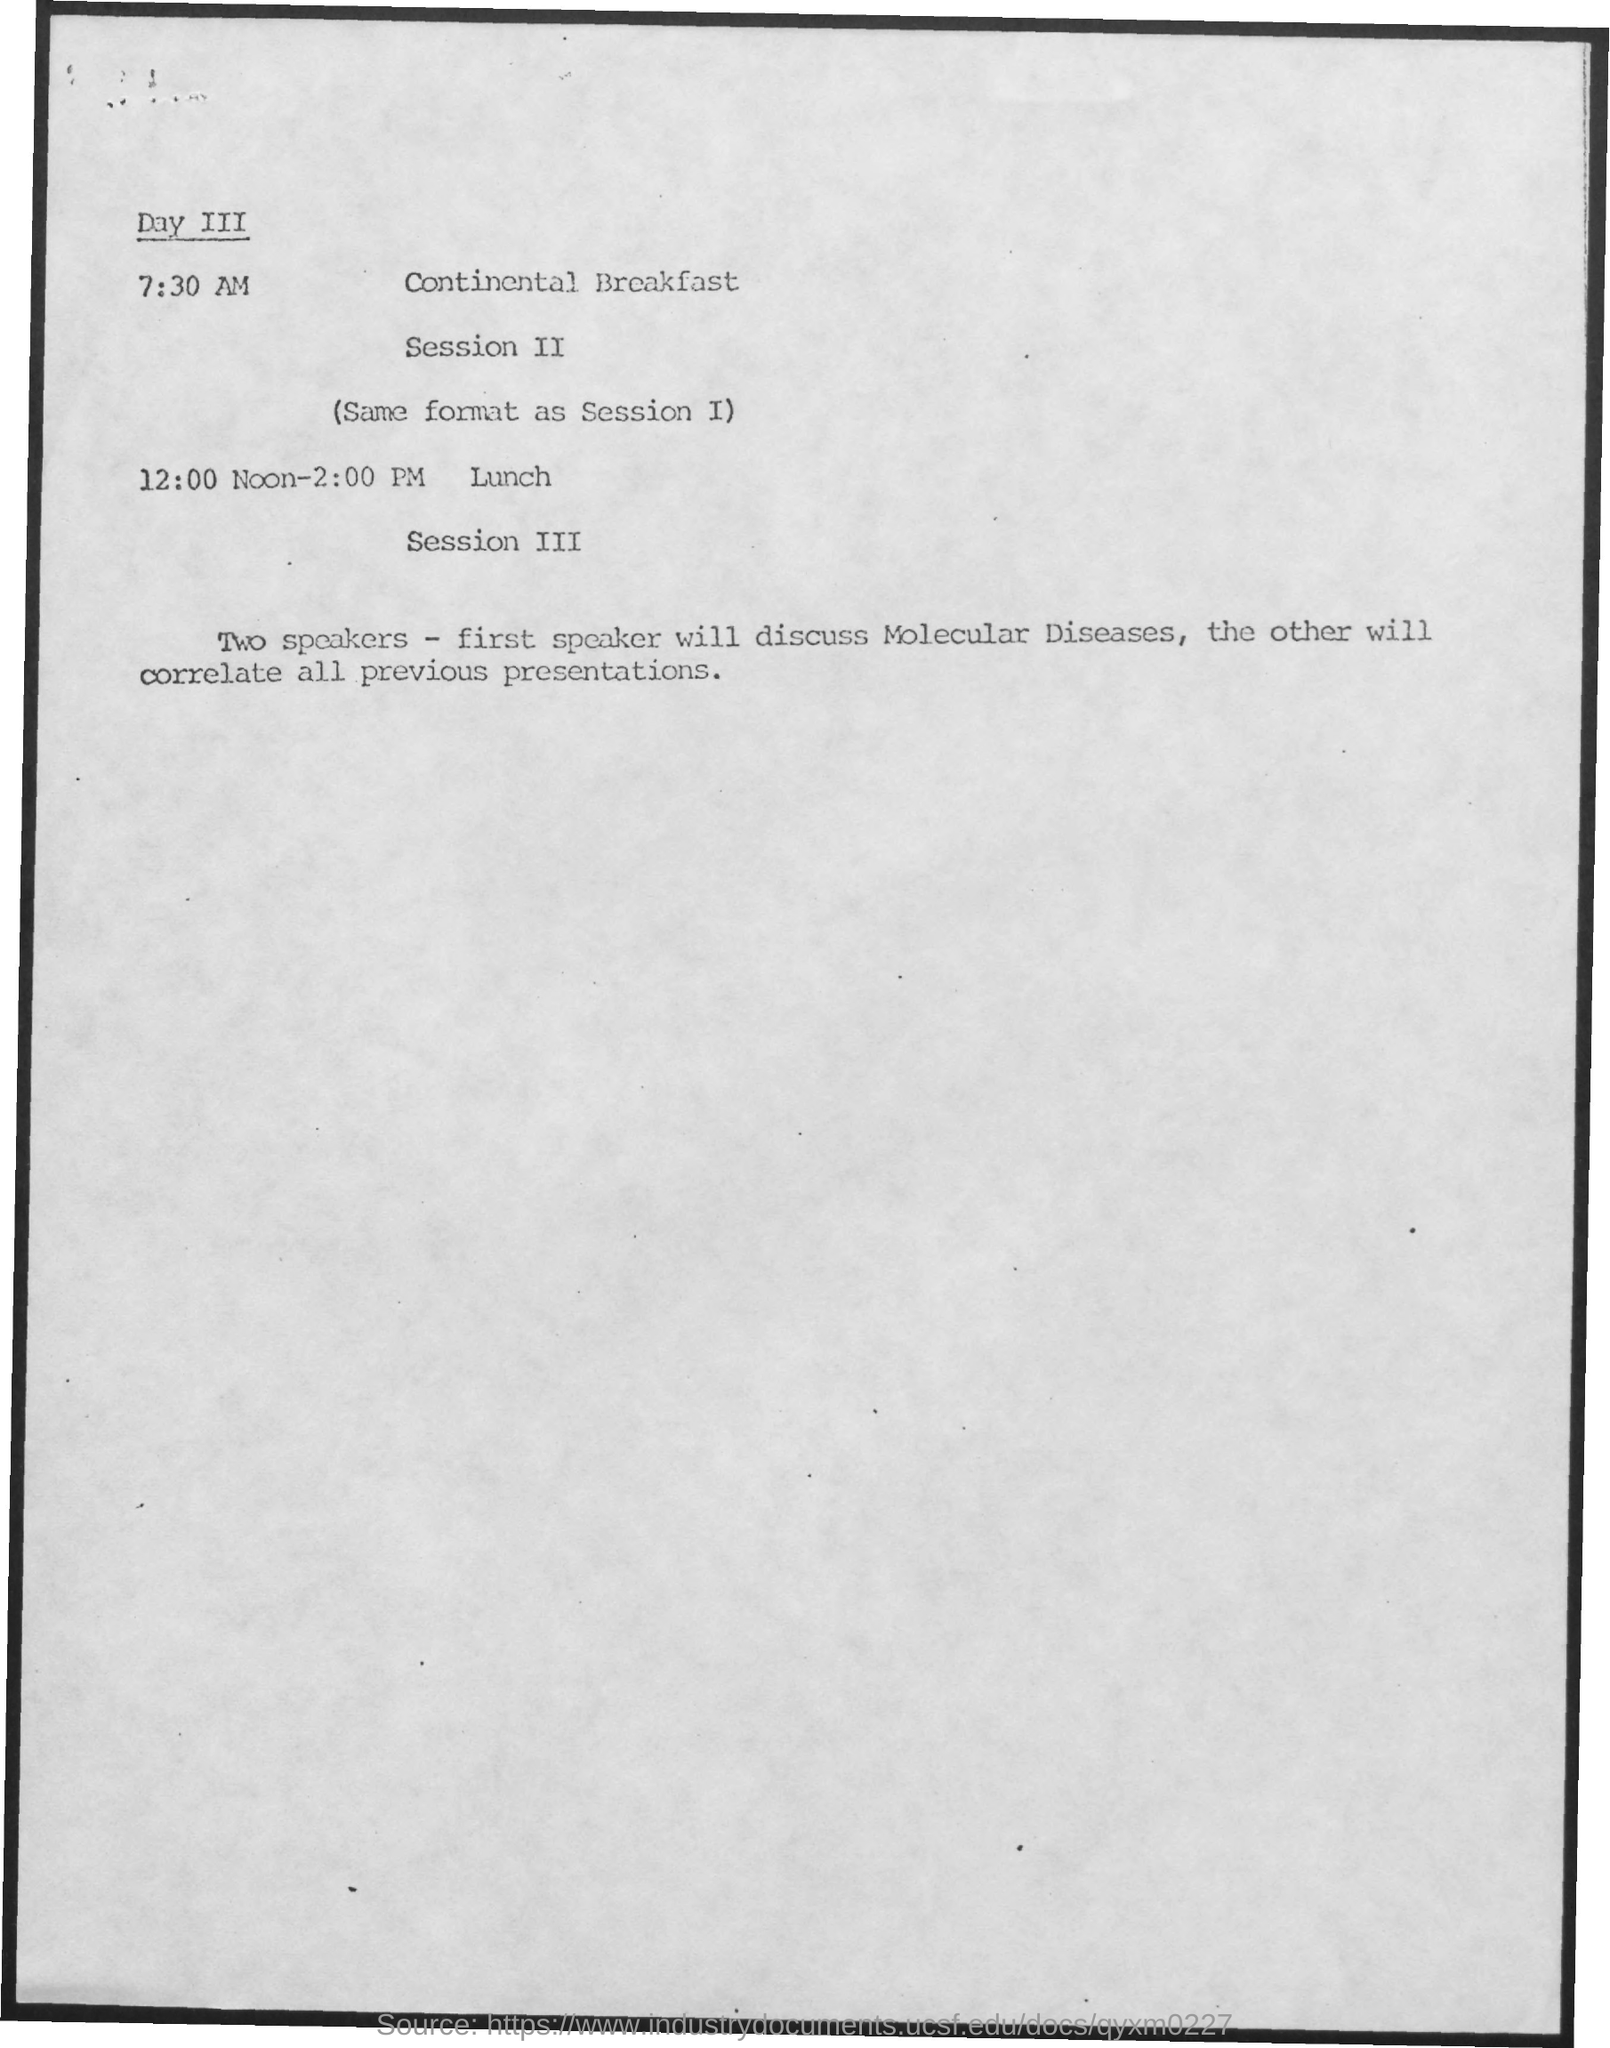What is the schedule at the time of 7:30 am?
Your answer should be very brief. Continental Breakfast. What is the schedule at the time of 12:00 noon- 2:00 pm ?
Make the answer very short. Lunch. 